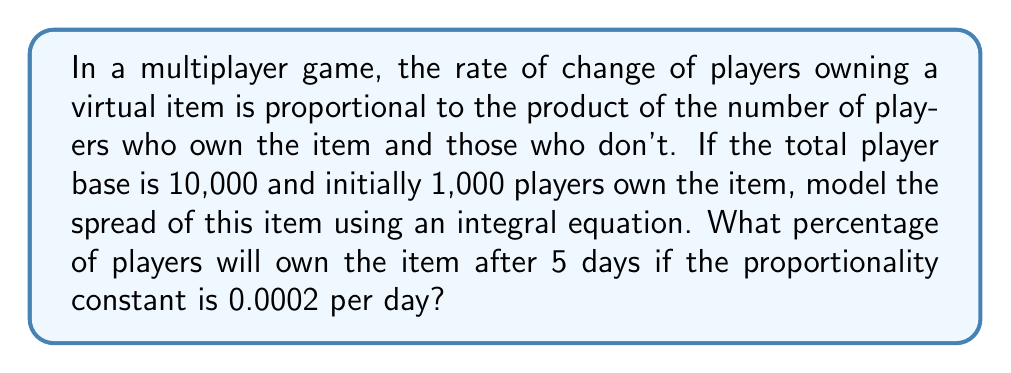Teach me how to tackle this problem. Let's approach this step-by-step:

1) Let $P(t)$ be the number of players who own the item at time $t$.

2) The rate of change can be modeled as:

   $$\frac{dP}{dt} = kP(N-P)$$

   where $k$ is the proportionality constant and $N$ is the total number of players.

3) Separating variables:

   $$\frac{dP}{P(N-P)} = k dt$$

4) Integrating both sides:

   $$\int_{P_0}^P \frac{dP}{P(N-P)} = \int_0^t k dt$$

5) The left side integrates to:

   $$\frac{1}{N} \ln\left(\frac{P}{N-P}\right) - \frac{1}{N} \ln\left(\frac{P_0}{N-P_0}\right) = kt$$

6) Solving for $P$:

   $$P = \frac{N}{1 + \left(\frac{N}{P_0} - 1\right)e^{-kNt}}$$

7) Plugging in the values: $N = 10000$, $P_0 = 1000$, $k = 0.0002$, $t = 5$:

   $$P = \frac{10000}{1 + \left(\frac{10000}{1000} - 1\right)e^{-0.0002 \cdot 10000 \cdot 5}}$$

8) Calculating:

   $$P \approx 5857.76$$

9) Converting to percentage:

   $$\frac{5857.76}{10000} \cdot 100\% \approx 58.58\%$$
Answer: 58.58% 